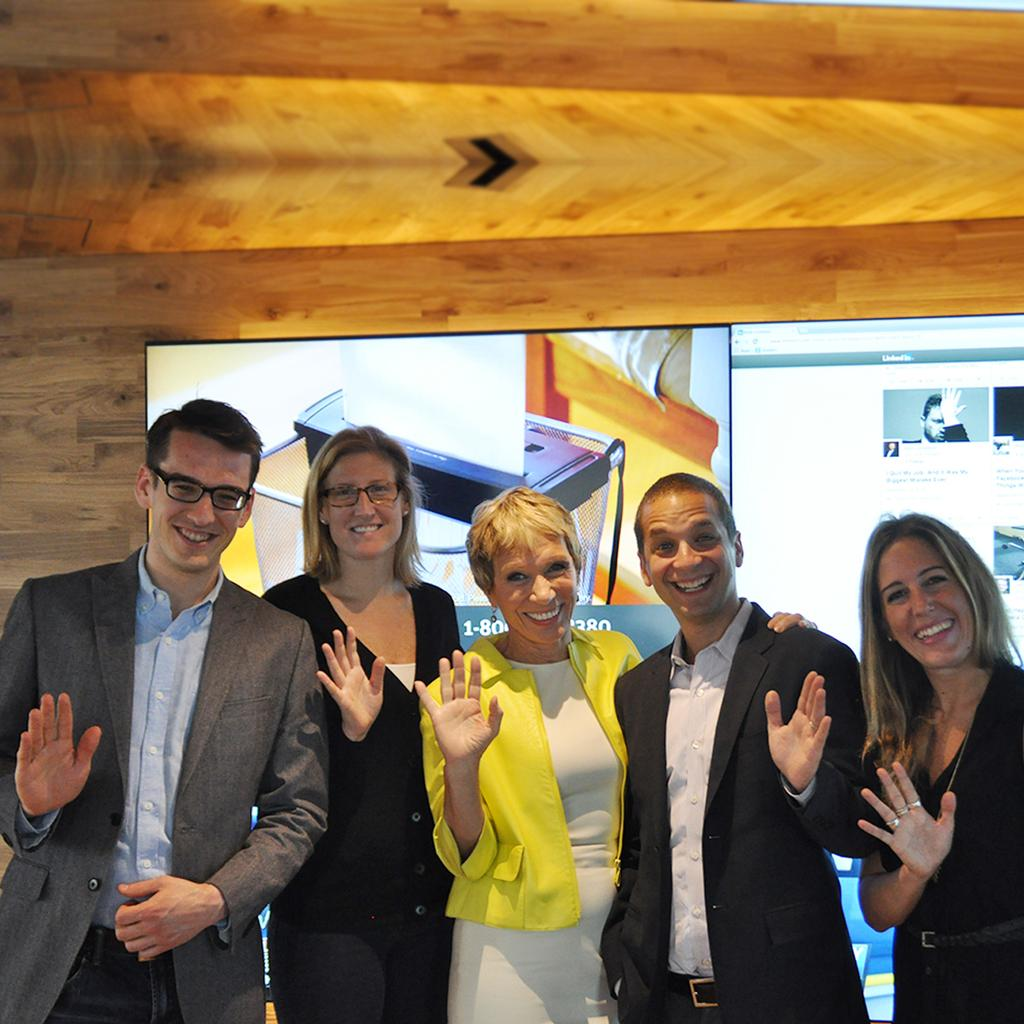What are the main subjects in the image? There are persons standing in the center of the image. What is the surface on which the persons are standing? The persons are standing on the ground. What can be seen in the background of the image? There is a screen and a wall in the background of the image. What type of collar can be seen on the rabbit in the image? There is no rabbit present in the image, and therefore no collar can be seen. What verse is being recited by the persons in the image? There is no indication in the image that the persons are reciting a verse, so it cannot be determined from the picture. 